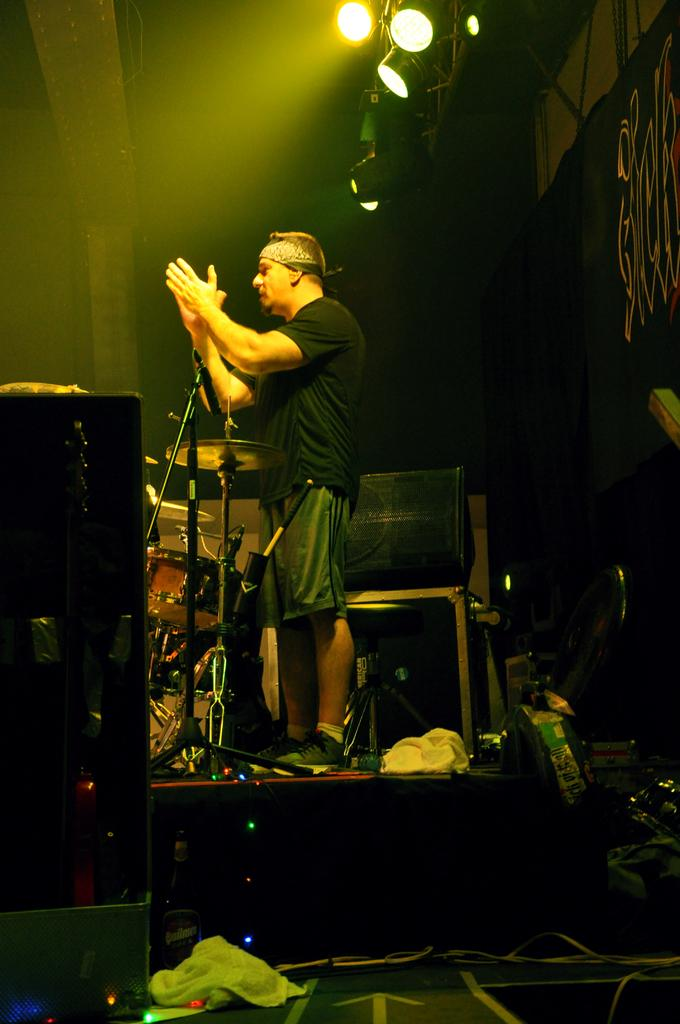What is the main subject of the image? There is a man standing in the image. Can you describe the man's attire? The man is wearing clothes, socks, and shoes. What can be seen in the background of the image? There are lights, a stand, cable wires, and musical instruments in the image. What type of vest is the man wearing in the image? The man is not wearing a vest in the image; he is only wearing clothes, socks, and shoes. What route does the man take to reach the musical instruments in the image? There is no indication of the man moving or taking a route in the image; he is simply standing. 